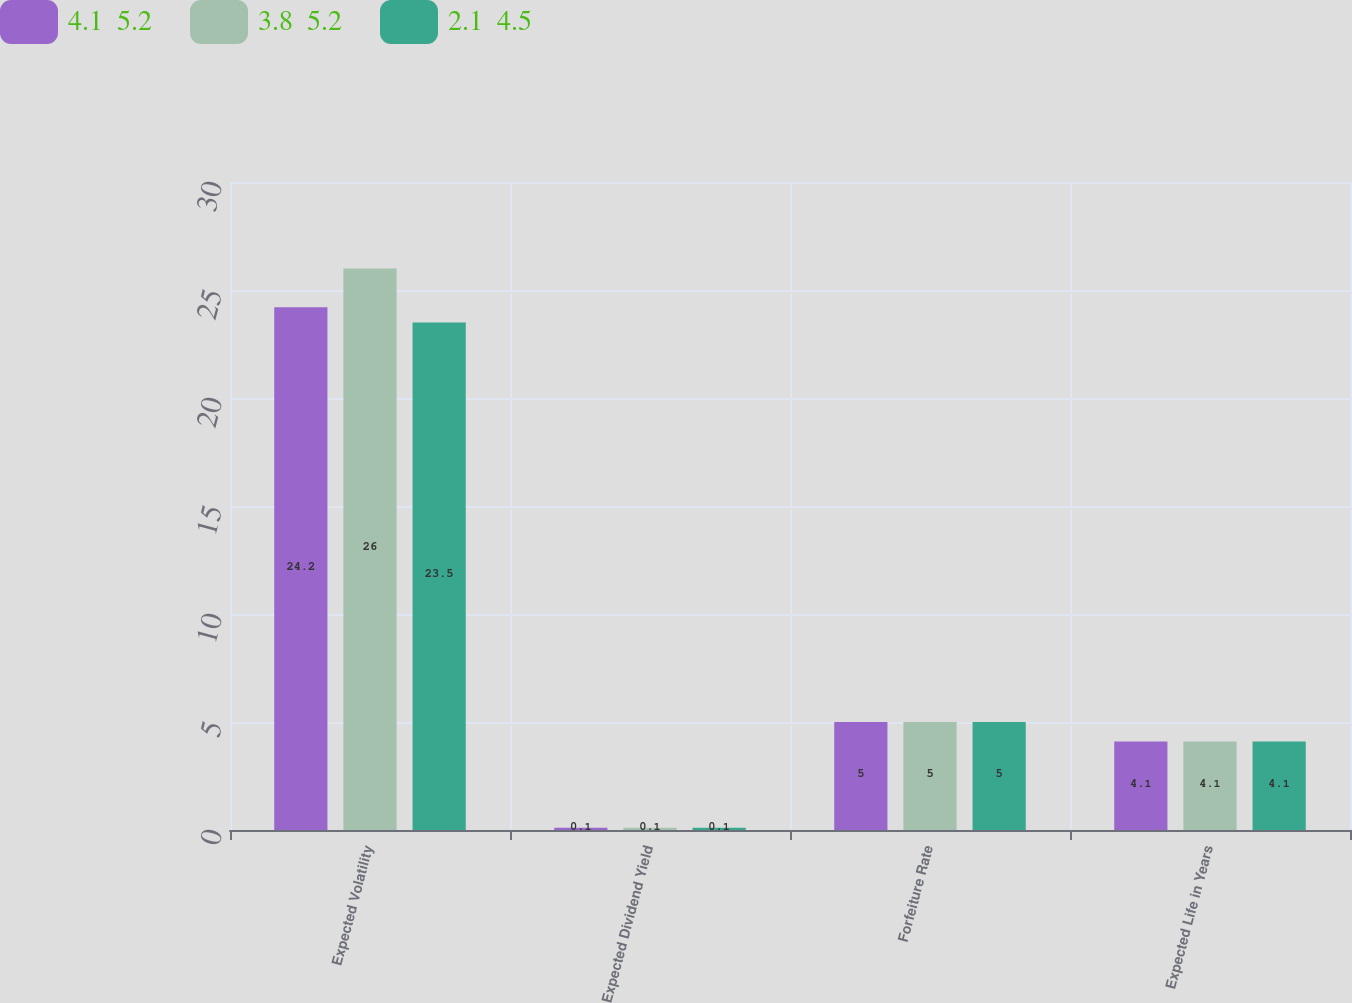<chart> <loc_0><loc_0><loc_500><loc_500><stacked_bar_chart><ecel><fcel>Expected Volatility<fcel>Expected Dividend Yield<fcel>Forfeiture Rate<fcel>Expected Life in Years<nl><fcel>4.1  5.2<fcel>24.2<fcel>0.1<fcel>5<fcel>4.1<nl><fcel>3.8  5.2<fcel>26<fcel>0.1<fcel>5<fcel>4.1<nl><fcel>2.1  4.5<fcel>23.5<fcel>0.1<fcel>5<fcel>4.1<nl></chart> 